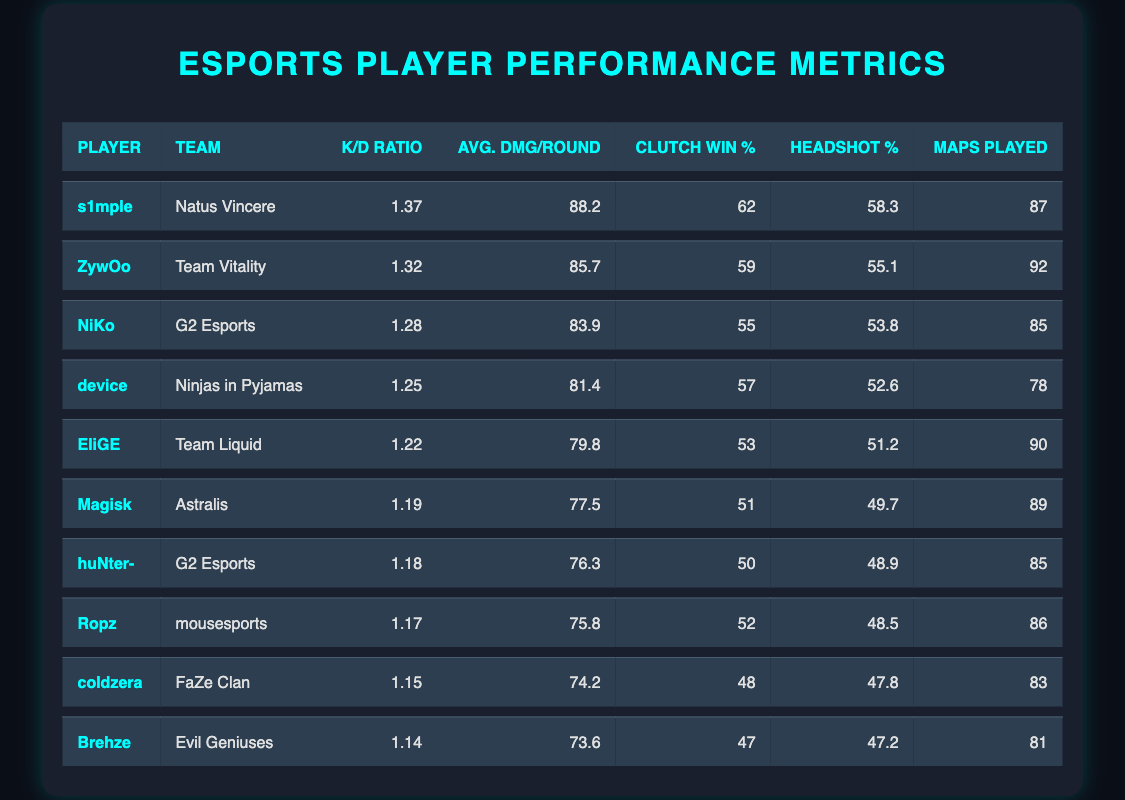What is the K/D ratio of s1mple? By looking at the row for s1mple, the K/D ratio is listed as 1.37.
Answer: 1.37 Which player has the highest average damage per round? The highest average damage per round can be found by scanning the "Avg. DMG/Round" column. In this case, s1mple has the highest average damage at 88.2.
Answer: s1mple How many maps did ZywOo play? The number of maps played by ZywOo can be directly found in his row in the "Maps Played" column, which is 92.
Answer: 92 What is the average K/D ratio of players in G2 Esports? Two players are from G2 Esports: NiKo with a K/D ratio of 1.28 and huNter- with a K/D ratio of 1.18. The average is calculated as (1.28 + 1.18) / 2 = 1.23.
Answer: 1.23 Did any player have a clutch win percentage over 60? s1mple has a clutch win percentage of 62, which is above 60. Checking the rest of the players confirms that he is the only one with such a statistic.
Answer: Yes Which player has the lowest headshot percentage? By checking the "Headshot %" column, Brehze has the lowest headshot percentage listed at 47.2.
Answer: Brehze Calculate the difference in K/D ratio between the top and bottom player in the table. The top player is s1mple with a K/D ratio of 1.37 and the bottom player is Brehze with a K/D ratio of 1.14. The difference is 1.37 - 1.14 = 0.23.
Answer: 0.23 How many players have a clutch win percentage of 50 or lower? The players with 50 or lower clutch win percentages are huNter- (50), Ropz (52), coldzera (48), and Brehze (47). Counting these gives us four players.
Answer: 4 Is there a player from Team Liquid with an average damage per round above 80? Yes, EliGE from Team Liquid has an average damage per round of 79.8, which is just below 80. The answer is no, since no player from Team Liquid exceeds 80.
Answer: No 